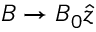Convert formula to latex. <formula><loc_0><loc_0><loc_500><loc_500>B \to B _ { 0 } \hat { z }</formula> 